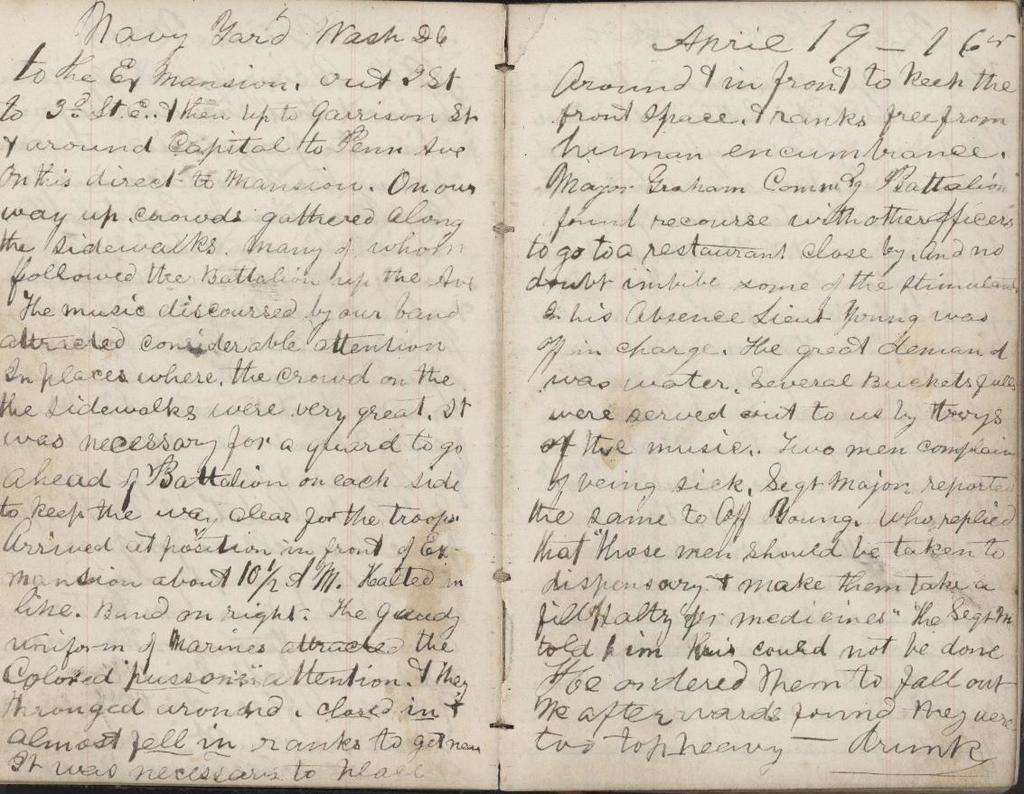<image>
Summarize the visual content of the image. A hand written book that says Navy Yard. 